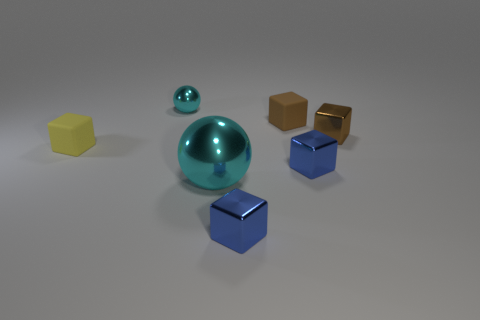Subtract all yellow blocks. How many blocks are left? 4 Subtract all small brown rubber blocks. How many blocks are left? 4 Subtract all red blocks. Subtract all gray cylinders. How many blocks are left? 5 Add 1 large metallic things. How many objects exist? 8 Subtract all balls. How many objects are left? 5 Add 2 metal blocks. How many metal blocks are left? 5 Add 7 large purple shiny cubes. How many large purple shiny cubes exist? 7 Subtract 0 red spheres. How many objects are left? 7 Subtract all yellow cubes. Subtract all tiny purple blocks. How many objects are left? 6 